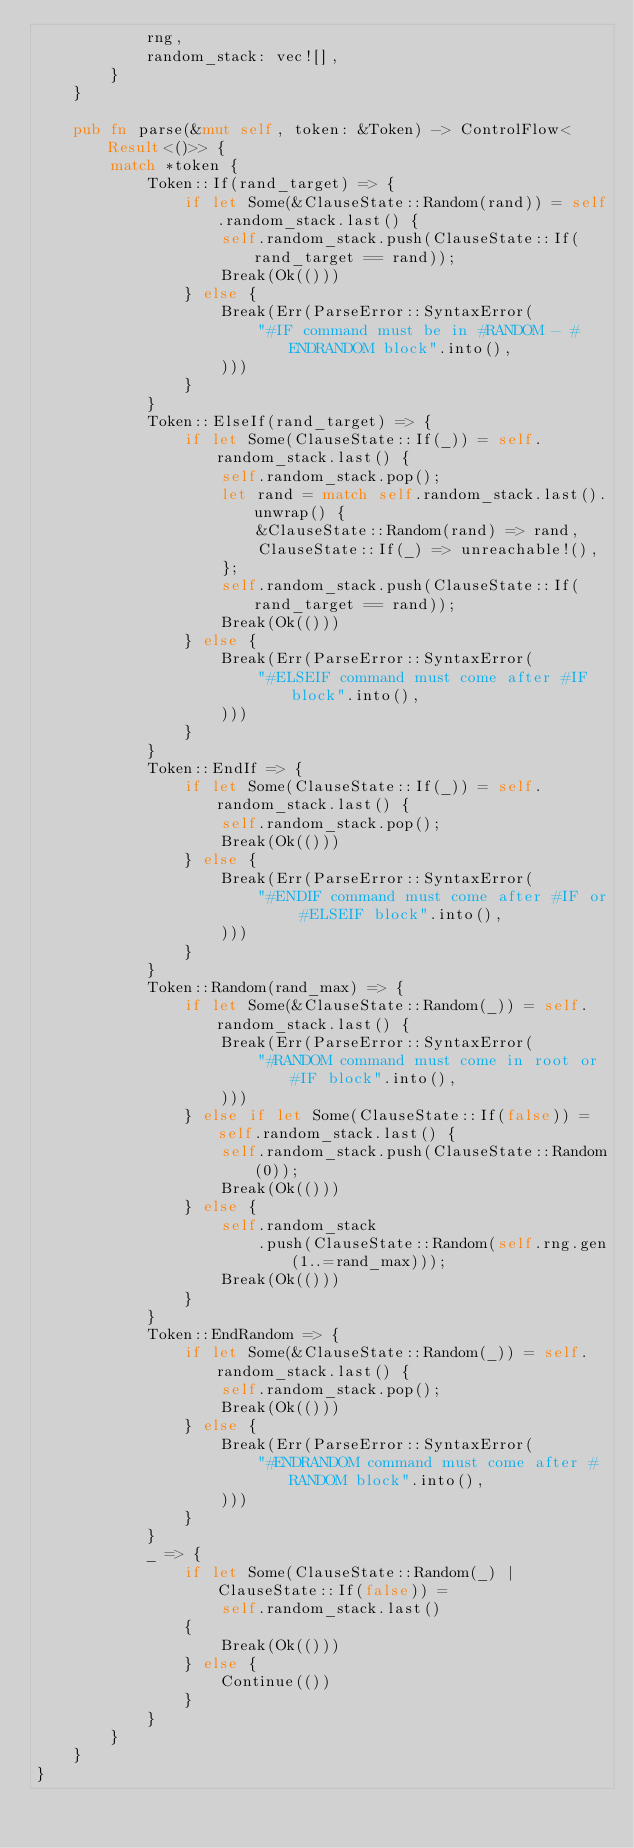<code> <loc_0><loc_0><loc_500><loc_500><_Rust_>            rng,
            random_stack: vec![],
        }
    }

    pub fn parse(&mut self, token: &Token) -> ControlFlow<Result<()>> {
        match *token {
            Token::If(rand_target) => {
                if let Some(&ClauseState::Random(rand)) = self.random_stack.last() {
                    self.random_stack.push(ClauseState::If(rand_target == rand));
                    Break(Ok(()))
                } else {
                    Break(Err(ParseError::SyntaxError(
                        "#IF command must be in #RANDOM - #ENDRANDOM block".into(),
                    )))
                }
            }
            Token::ElseIf(rand_target) => {
                if let Some(ClauseState::If(_)) = self.random_stack.last() {
                    self.random_stack.pop();
                    let rand = match self.random_stack.last().unwrap() {
                        &ClauseState::Random(rand) => rand,
                        ClauseState::If(_) => unreachable!(),
                    };
                    self.random_stack.push(ClauseState::If(rand_target == rand));
                    Break(Ok(()))
                } else {
                    Break(Err(ParseError::SyntaxError(
                        "#ELSEIF command must come after #IF block".into(),
                    )))
                }
            }
            Token::EndIf => {
                if let Some(ClauseState::If(_)) = self.random_stack.last() {
                    self.random_stack.pop();
                    Break(Ok(()))
                } else {
                    Break(Err(ParseError::SyntaxError(
                        "#ENDIF command must come after #IF or #ELSEIF block".into(),
                    )))
                }
            }
            Token::Random(rand_max) => {
                if let Some(&ClauseState::Random(_)) = self.random_stack.last() {
                    Break(Err(ParseError::SyntaxError(
                        "#RANDOM command must come in root or #IF block".into(),
                    )))
                } else if let Some(ClauseState::If(false)) = self.random_stack.last() {
                    self.random_stack.push(ClauseState::Random(0));
                    Break(Ok(()))
                } else {
                    self.random_stack
                        .push(ClauseState::Random(self.rng.gen(1..=rand_max)));
                    Break(Ok(()))
                }
            }
            Token::EndRandom => {
                if let Some(&ClauseState::Random(_)) = self.random_stack.last() {
                    self.random_stack.pop();
                    Break(Ok(()))
                } else {
                    Break(Err(ParseError::SyntaxError(
                        "#ENDRANDOM command must come after #RANDOM block".into(),
                    )))
                }
            }
            _ => {
                if let Some(ClauseState::Random(_) | ClauseState::If(false)) =
                    self.random_stack.last()
                {
                    Break(Ok(()))
                } else {
                    Continue(())
                }
            }
        }
    }
}
</code> 